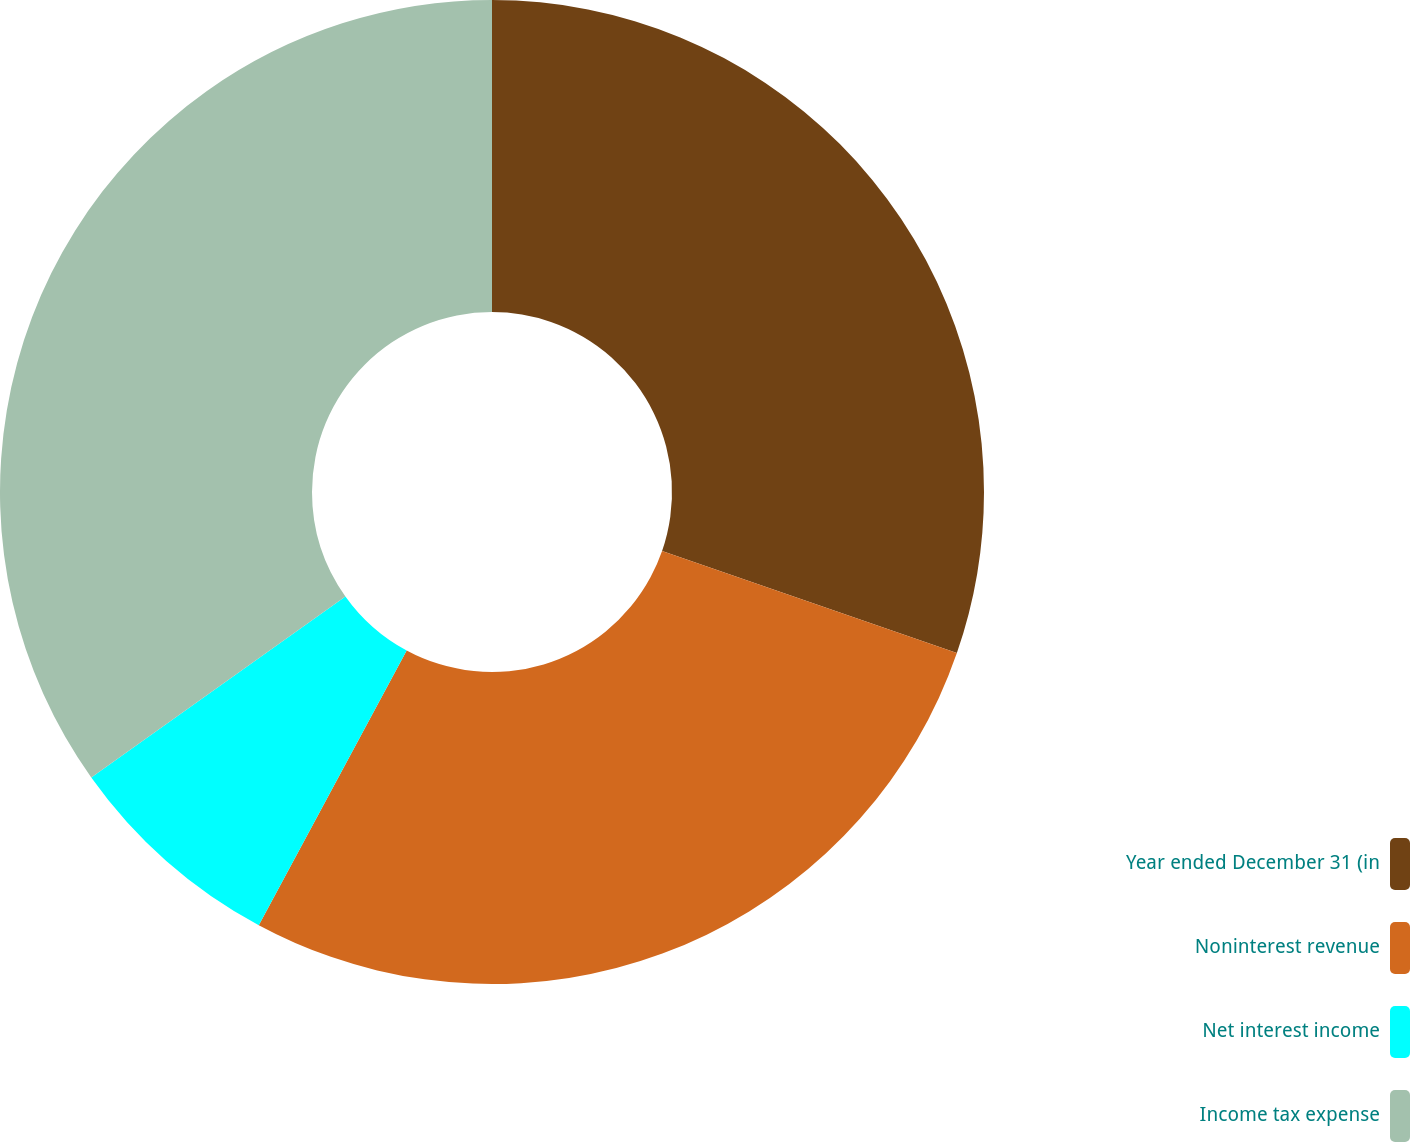Convert chart. <chart><loc_0><loc_0><loc_500><loc_500><pie_chart><fcel>Year ended December 31 (in<fcel>Noninterest revenue<fcel>Net interest income<fcel>Income tax expense<nl><fcel>30.31%<fcel>27.55%<fcel>7.29%<fcel>34.85%<nl></chart> 